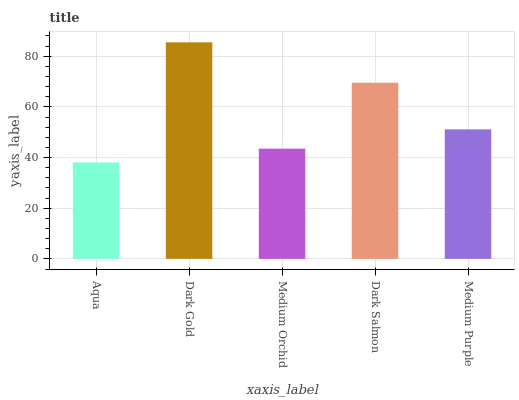Is Aqua the minimum?
Answer yes or no. Yes. Is Dark Gold the maximum?
Answer yes or no. Yes. Is Medium Orchid the minimum?
Answer yes or no. No. Is Medium Orchid the maximum?
Answer yes or no. No. Is Dark Gold greater than Medium Orchid?
Answer yes or no. Yes. Is Medium Orchid less than Dark Gold?
Answer yes or no. Yes. Is Medium Orchid greater than Dark Gold?
Answer yes or no. No. Is Dark Gold less than Medium Orchid?
Answer yes or no. No. Is Medium Purple the high median?
Answer yes or no. Yes. Is Medium Purple the low median?
Answer yes or no. Yes. Is Medium Orchid the high median?
Answer yes or no. No. Is Medium Orchid the low median?
Answer yes or no. No. 